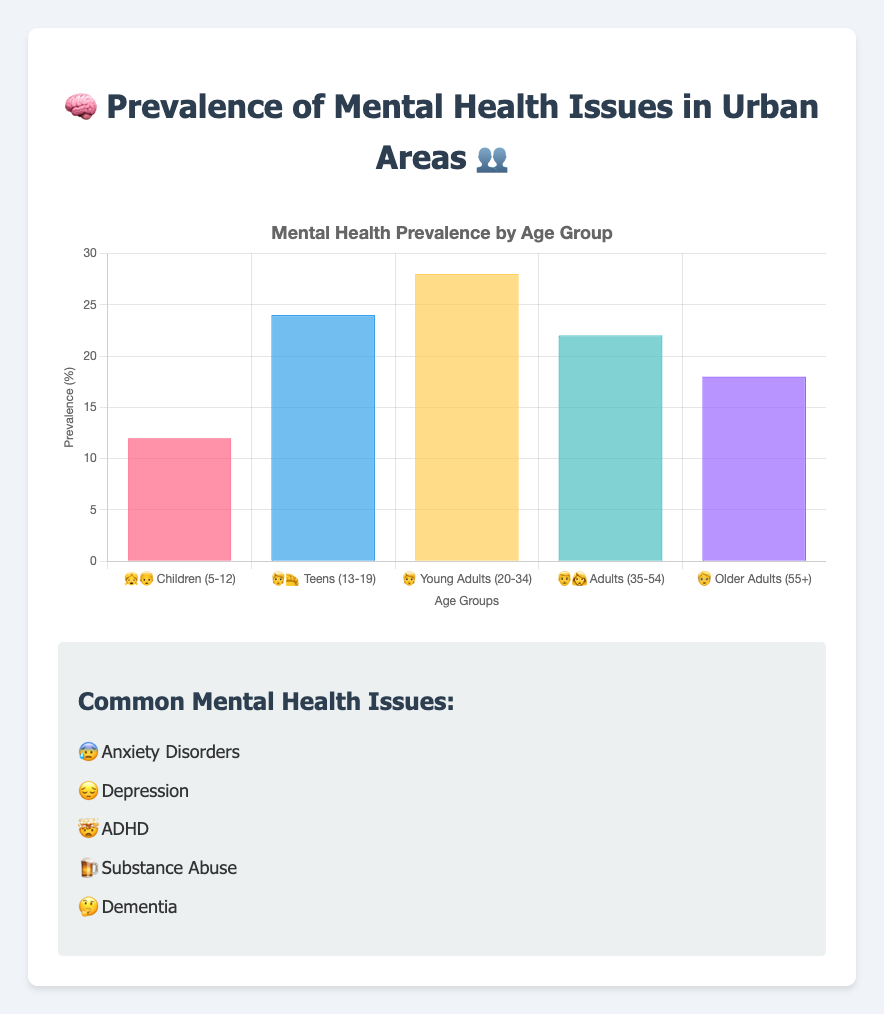What's the title of the figure? The title is usually positioned at the top of the chart. By reading the section at the top, we can see that the title is "🧠 Prevalence of Mental Health Issues in Urban Areas 👥"
Answer: 🧠 Prevalence of Mental Health Issues in Urban Areas 👥 Which age group has the highest prevalence of mental health issues? By looking at the height of the bars, we see that "Young Adults (20-34) 🧑" has the tallest bar with a prevalence of 28%
Answer: Young Adults (20-34) 🧑 What is the prevalence percentage for Adults (35-54) 👨👩? Refer to the bar labeled "👨👩 Adults (35-54)" and note the height which corresponds to the value 22%
Answer: 22% How does the prevalence for Teens (13-19) 🧑‍🦱 compare against Older Adults (55+) 🧓? By comparing the two bars for Teens and Older Adults, we see that "Teens (13-19) 🧑‍🦱" have a higher prevalence (24%) compared to "Older Adults (55+) 🧓" (18%)
Answer: Teens (13-19) 🧑‍🦱 have a higher prevalence What's the average prevalence percentage across all age groups? Add the prevalence percentages of all age groups: (12 + 24 + 28 + 22 + 18) = 104. Then, divide by the number of age groups, which is 5: 104 / 5 = 20.8
Answer: 20.8% What is the difference in prevalence between Children (5-12) 👧👦 and Young Adults (20-34) 🧑? Subtract the prevalence percentage of Children from that of Young Adults: 28% - 12% = 16%
Answer: 16% Which common mental health issue is symbolized by the emoji "😔"? By referring to the list of common mental health issues, "😔" represents Depression
Answer: Depression How many percentage points higher is the prevalence in Young Adults (20-34) 🧑 compared to Adults (35-54) 👨👩? Subtract the prevalence percentage of Adults from that of Young Adults: 28% - 22% = 6%
Answer: 6% What are the two age groups with prevalence percentages above 20%? By examining the bars, the age groups "Teens (13-19) 🧑‍🦱" with 24% and "Young Adults (20-34) 🧑" with 28% have percentages above 20%
Answer: Teens (13-19) 🧑‍🦱, Young Adults (20-34) 🧑 